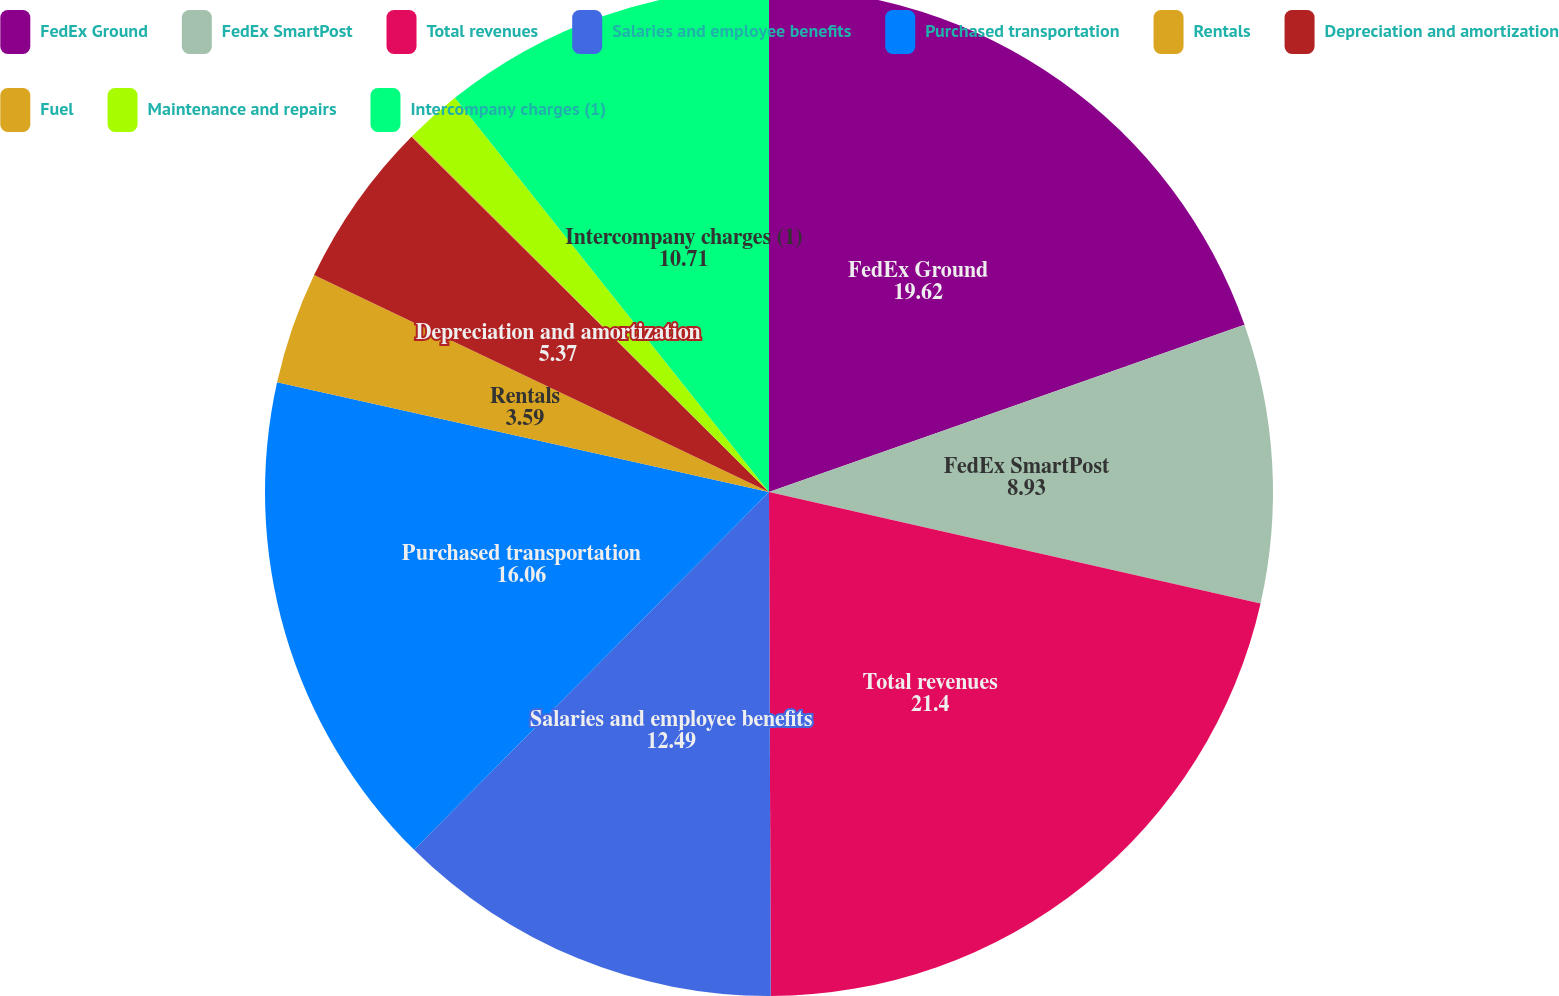Convert chart to OTSL. <chart><loc_0><loc_0><loc_500><loc_500><pie_chart><fcel>FedEx Ground<fcel>FedEx SmartPost<fcel>Total revenues<fcel>Salaries and employee benefits<fcel>Purchased transportation<fcel>Rentals<fcel>Depreciation and amortization<fcel>Fuel<fcel>Maintenance and repairs<fcel>Intercompany charges (1)<nl><fcel>19.62%<fcel>8.93%<fcel>21.4%<fcel>12.49%<fcel>16.06%<fcel>3.59%<fcel>5.37%<fcel>0.03%<fcel>1.81%<fcel>10.71%<nl></chart> 